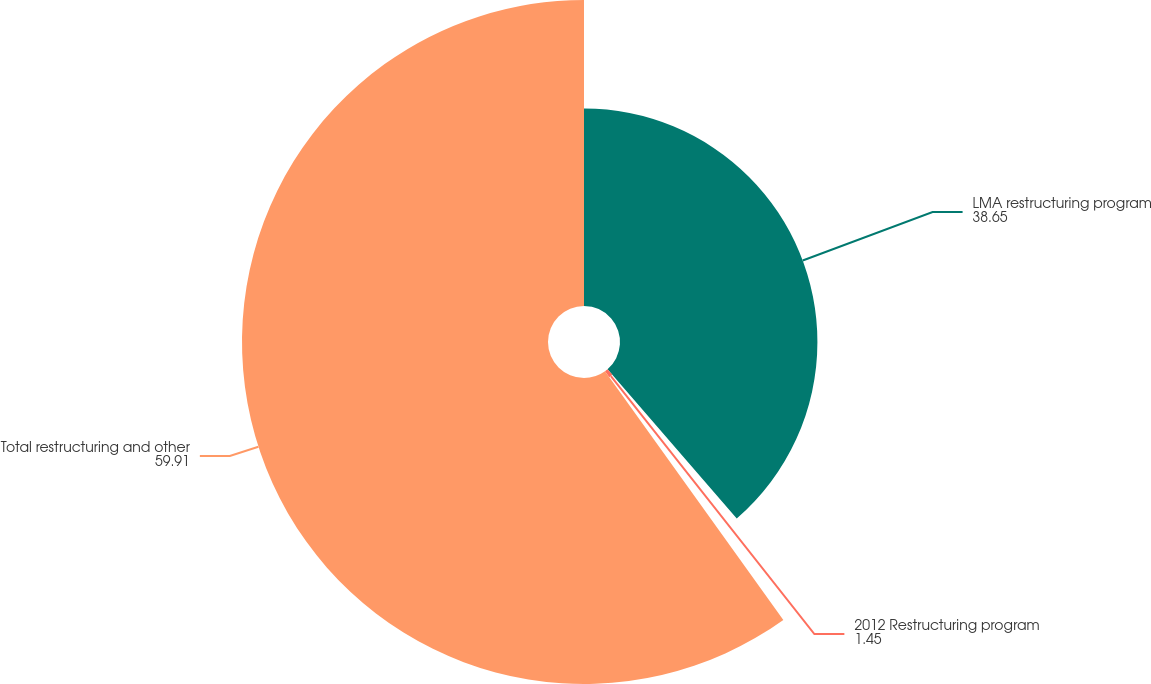Convert chart. <chart><loc_0><loc_0><loc_500><loc_500><pie_chart><fcel>LMA restructuring program<fcel>2012 Restructuring program<fcel>Total restructuring and other<nl><fcel>38.65%<fcel>1.45%<fcel>59.91%<nl></chart> 